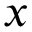Convert formula to latex. <formula><loc_0><loc_0><loc_500><loc_500>x</formula> 